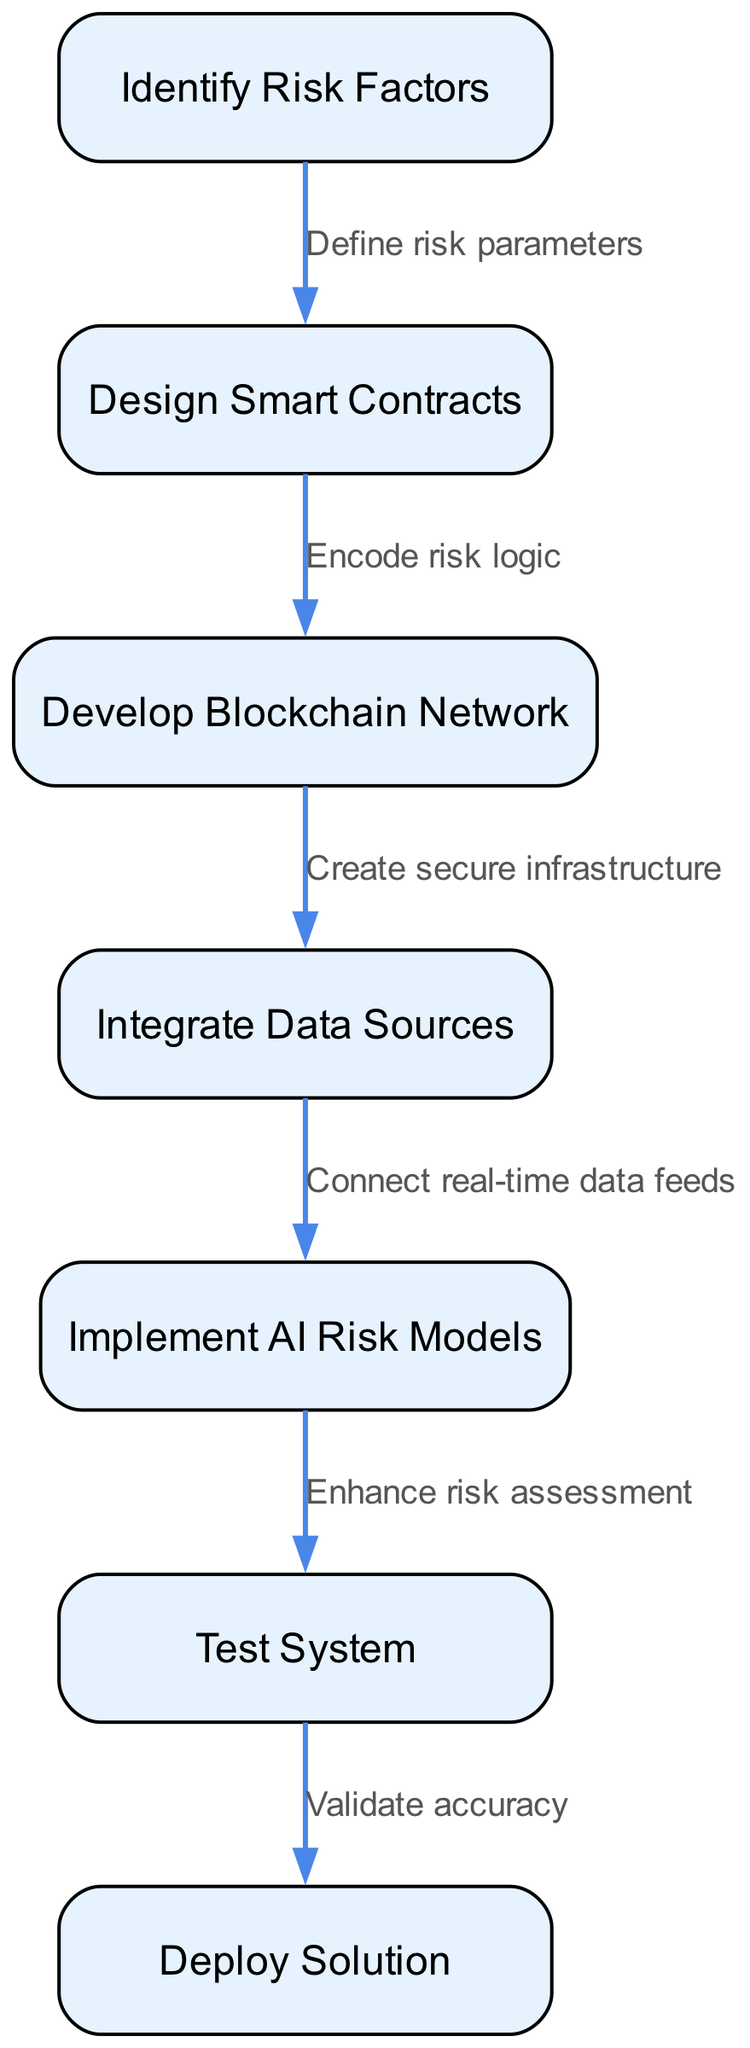What is the first step in the blockchain-based risk assessment system? The first node in the diagram is "Identify Risk Factors." It initiates the process of implementing the blockchain-based system.
Answer: Identify Risk Factors How many nodes are present in the diagram? By counting the individual steps represented as nodes in the diagram, there are a total of 7 nodes.
Answer: 7 What does the edge between "Design Smart Contracts" and "Develop Blockchain Network" represent? This edge is labeled "Encode risk logic," indicating that in order to develop the blockchain network, the system must first encode the logic related to risk defined in the smart contracts.
Answer: Encode risk logic Which step integrates real-time data feeds? The step "Integrate Data Sources" connects real-time data feeds to the system, facilitating the input of live data for risk assessment.
Answer: Integrate Data Sources What is the final step in the risk assessment system implementation? The last step noted in the diagram is "Deploy Solution," which concludes the process of implementing the blockchain-based risk assessment system.
Answer: Deploy Solution Which node follows "Test System" in the diagram? The node that follows "Test System" is "Deploy Solution," indicating that after testing, the system is ready for deployment.
Answer: Deploy Solution What is required before implementing AI Risk Models? Prior to implementing AI Risk Models, it is necessary to "Integrate Data Sources" to ensure that the models have the relevant data they need for accurate assessments.
Answer: Integrate Data Sources What action is associated with moving from "Identify Risk Factors" to "Design Smart Contracts"? This transition is defined by the action "Define risk parameters," as it specifies the parameters that need to be defined for creating the smart contracts.
Answer: Define risk parameters 